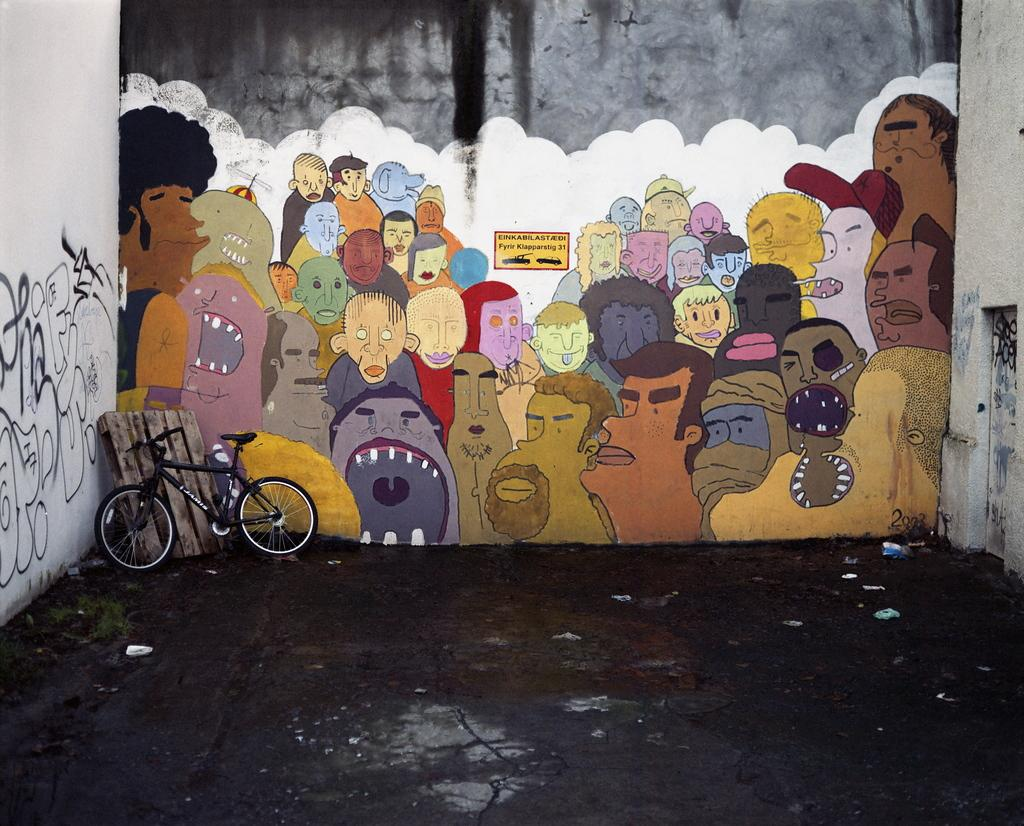What type of surface is visible in the image? There is a pavement in the image. What surrounds the pavement? There are walls on either side of the pavement. What can be seen in the background of the image? There is a bicycle, a wooden surface, and a wall with painting in the background of the image. What type of food is being prepared by the creator in the image? There is no creator or food preparation visible in the image. What type of tail can be seen on the animal in the image? There are no animals or tails present in the image. 